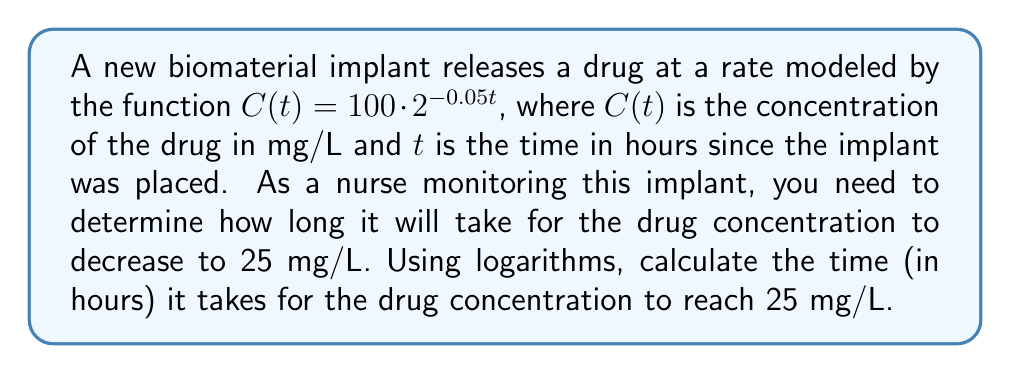Solve this math problem. Let's solve this step-by-step using logarithms:

1) We start with the equation: $C(t) = 100 \cdot 2^{-0.05t}$

2) We want to find $t$ when $C(t) = 25$, so we set up the equation:
   $25 = 100 \cdot 2^{-0.05t}$

3) Divide both sides by 100:
   $\frac{25}{100} = 2^{-0.05t}$
   $0.25 = 2^{-0.05t}$

4) Take the logarithm (base 2) of both sides:
   $\log_2(0.25) = \log_2(2^{-0.05t})$

5) Using the logarithm property $\log_a(a^x) = x$, we get:
   $\log_2(0.25) = -0.05t$

6) Solve for $t$:
   $t = -\frac{\log_2(0.25)}{0.05}$

7) We can change the base of the logarithm to a more common base (e or 10) using the change of base formula:
   $t = -\frac{\ln(0.25)}{0.05 \ln(2)}$ or $t = -\frac{\log(0.25)}{0.05 \log(2)}$

8) Calculate the result:
   $t \approx 28.53$ hours

Therefore, it will take approximately 28.53 hours for the drug concentration to decrease to 25 mg/L.
Answer: 28.53 hours 